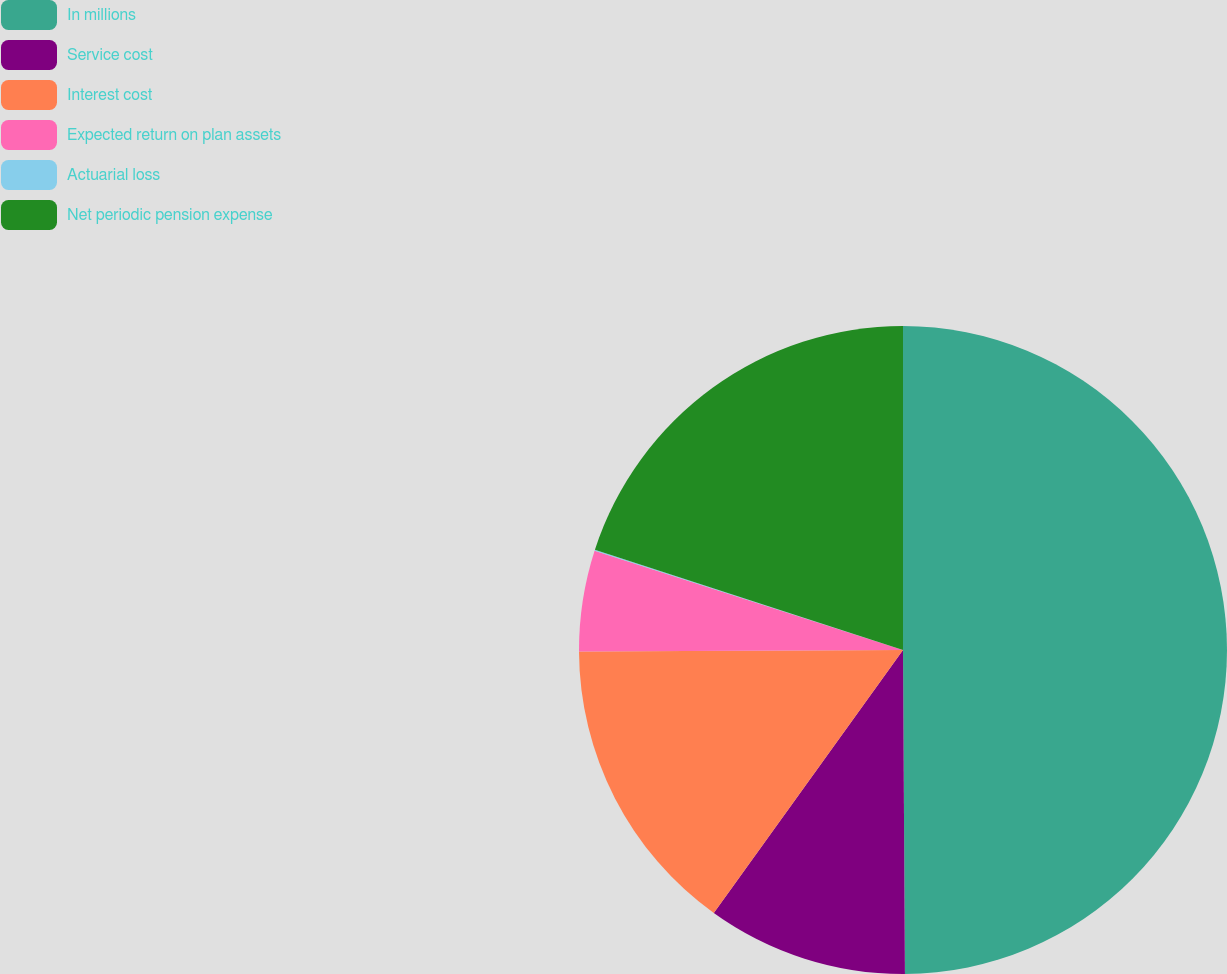Convert chart. <chart><loc_0><loc_0><loc_500><loc_500><pie_chart><fcel>In millions<fcel>Service cost<fcel>Interest cost<fcel>Expected return on plan assets<fcel>Actuarial loss<fcel>Net periodic pension expense<nl><fcel>49.9%<fcel>10.02%<fcel>15.0%<fcel>5.03%<fcel>0.05%<fcel>19.99%<nl></chart> 